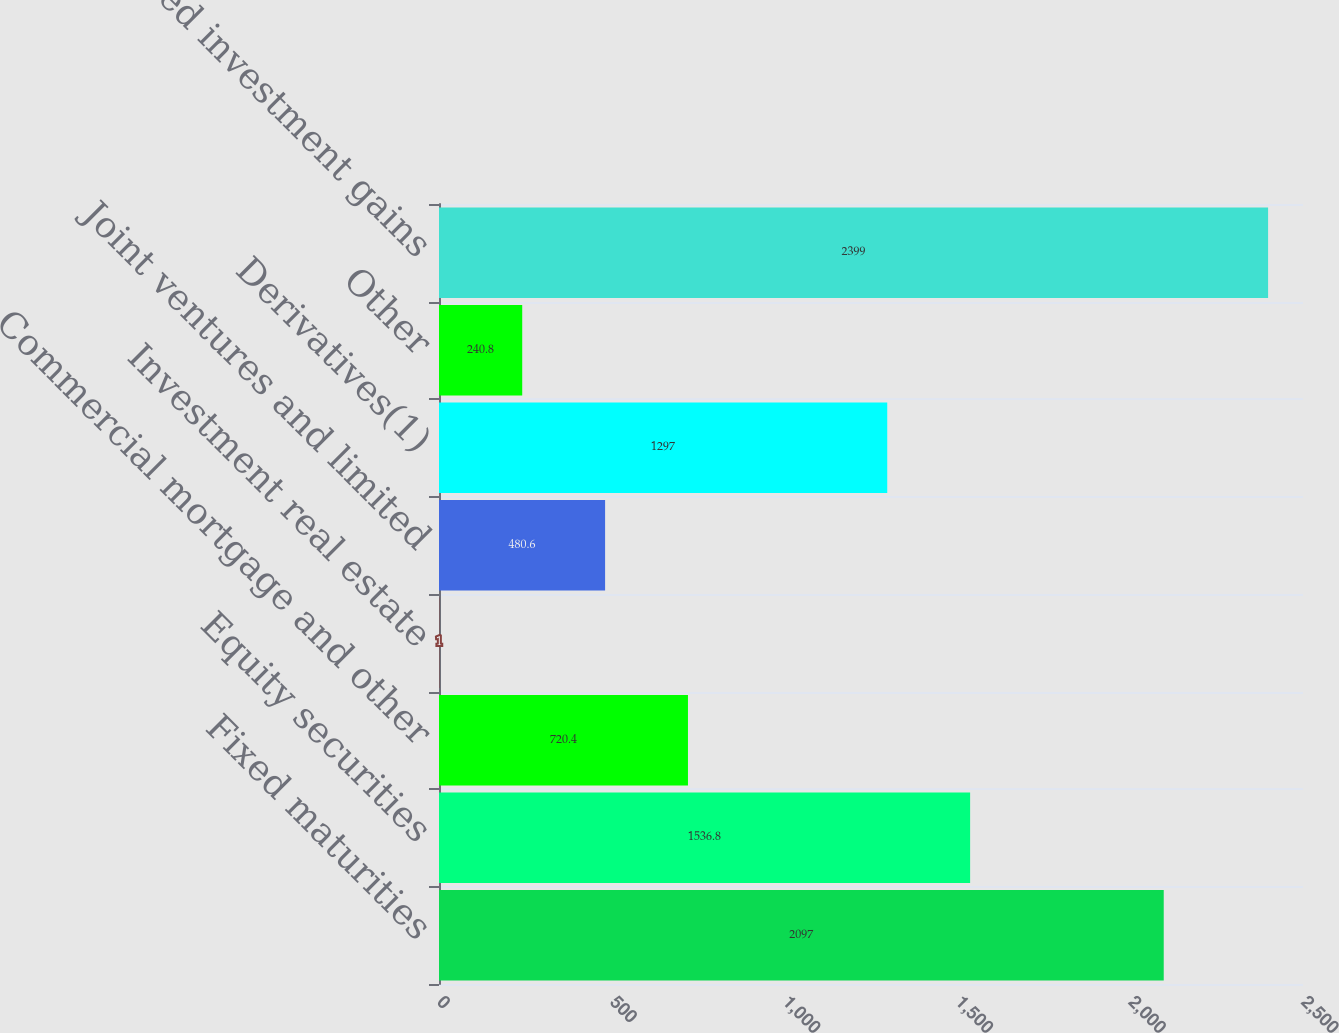<chart> <loc_0><loc_0><loc_500><loc_500><bar_chart><fcel>Fixed maturities<fcel>Equity securities<fcel>Commercial mortgage and other<fcel>Investment real estate<fcel>Joint ventures and limited<fcel>Derivatives(1)<fcel>Other<fcel>Realized investment gains<nl><fcel>2097<fcel>1536.8<fcel>720.4<fcel>1<fcel>480.6<fcel>1297<fcel>240.8<fcel>2399<nl></chart> 